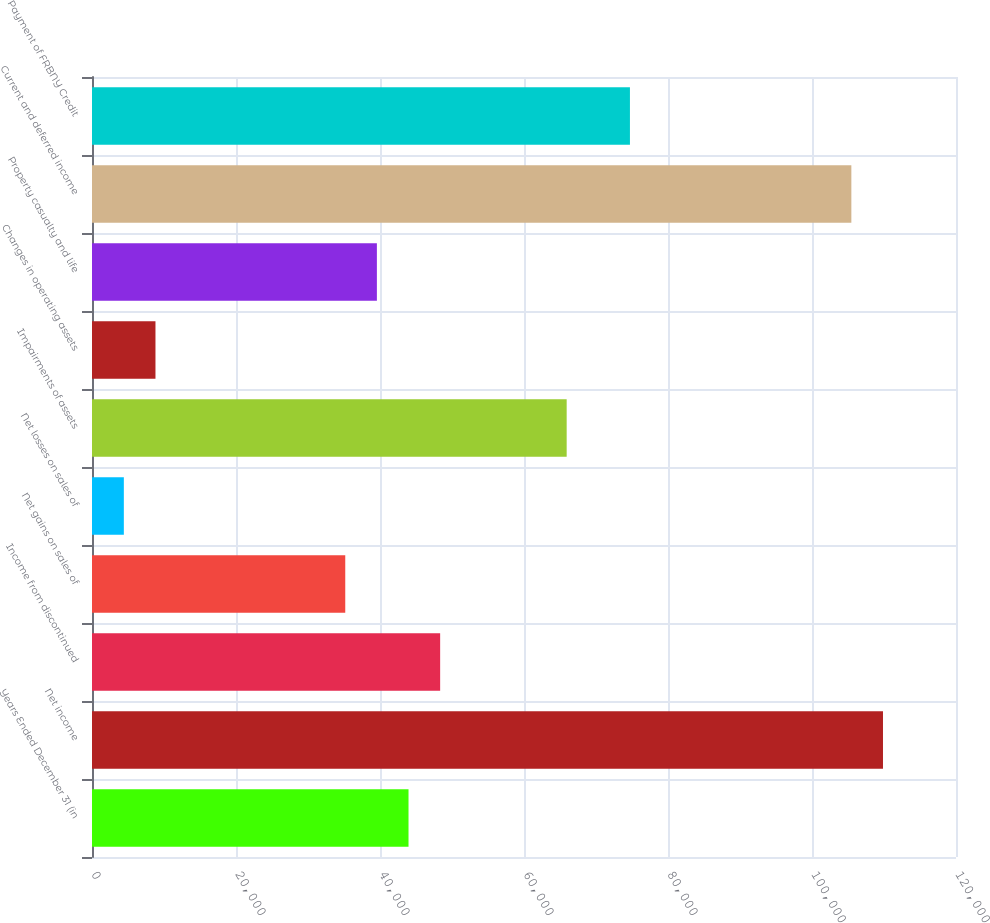Convert chart. <chart><loc_0><loc_0><loc_500><loc_500><bar_chart><fcel>Years Ended December 31 (in<fcel>Net income<fcel>Income from discontinued<fcel>Net gains on sales of<fcel>Net losses on sales of<fcel>Impairments of assets<fcel>Changes in operating assets<fcel>Property casualty and life<fcel>Current and deferred income<fcel>Payment of FRBNY Credit<nl><fcel>43961<fcel>109859<fcel>48354.2<fcel>35174.6<fcel>4422.2<fcel>65927<fcel>8815.4<fcel>39567.8<fcel>105466<fcel>74713.4<nl></chart> 